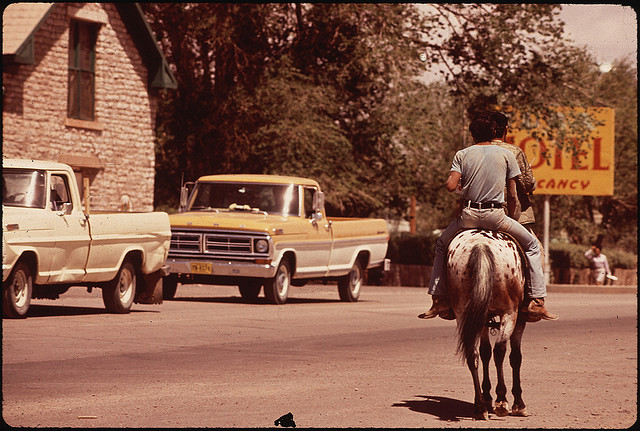<image>What country is this in? I don't know what country this is in. It could be in Mexico, USA, or Spain. What country is this in? I don't know what country this is in. It can be either Mexico, USA, or Spain. 